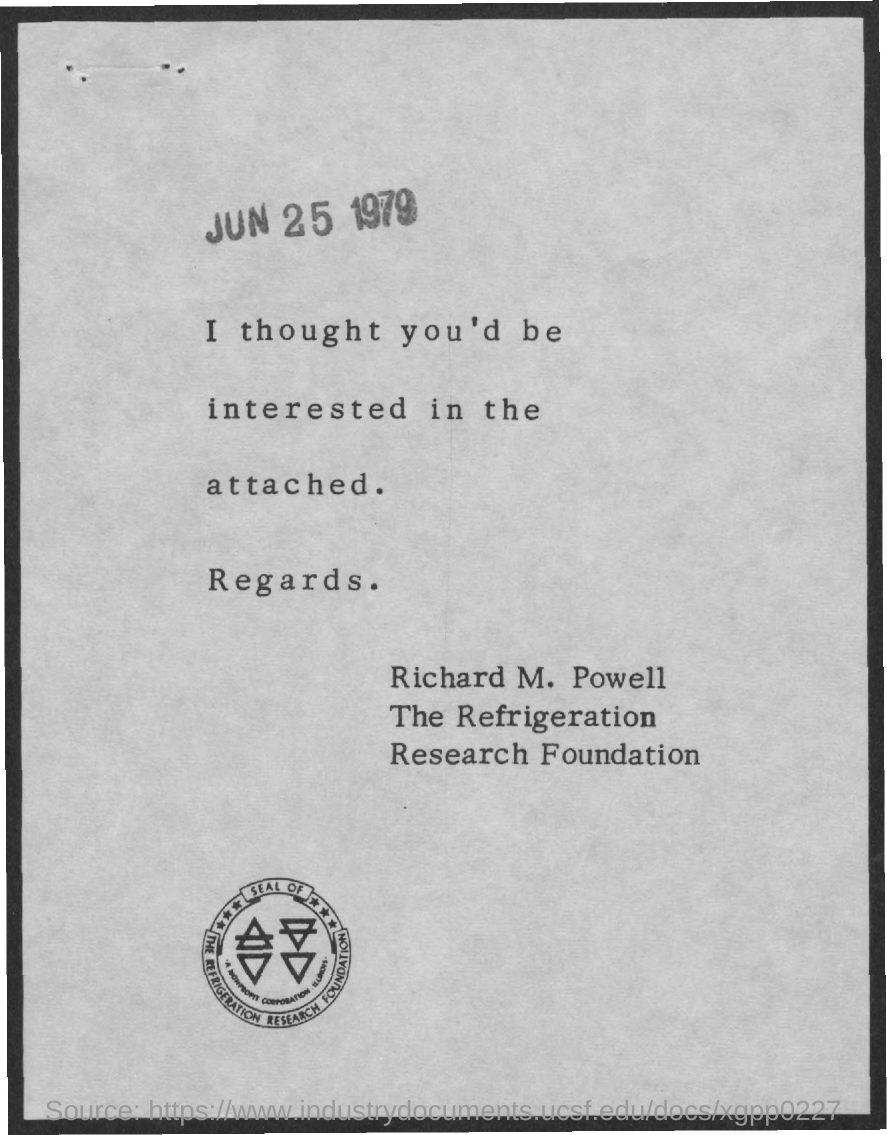Draw attention to some important aspects in this diagram. The seal of the refrigeration research foundation is given here. The document is dated June 25, 1979. 